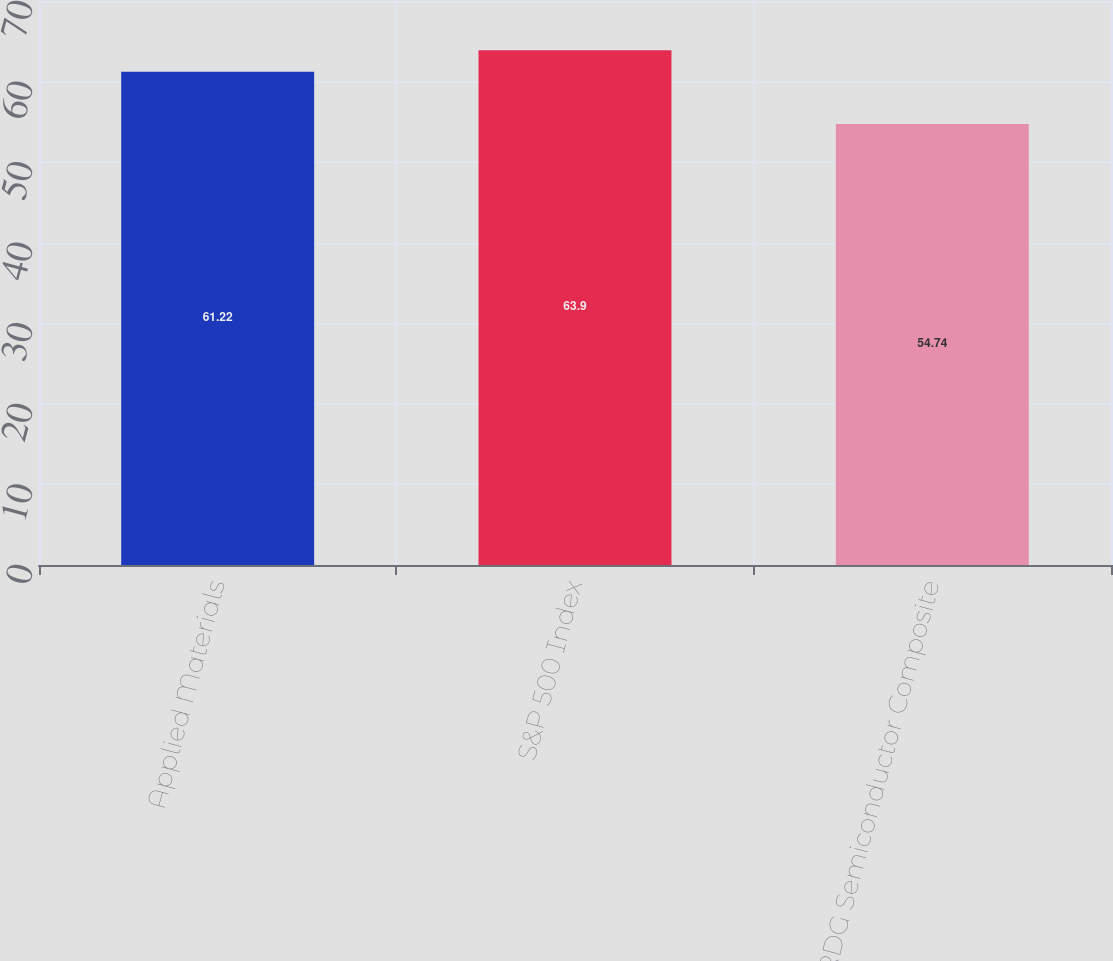Convert chart to OTSL. <chart><loc_0><loc_0><loc_500><loc_500><bar_chart><fcel>Applied Materials<fcel>S&P 500 Index<fcel>RDG Semiconductor Composite<nl><fcel>61.22<fcel>63.9<fcel>54.74<nl></chart> 